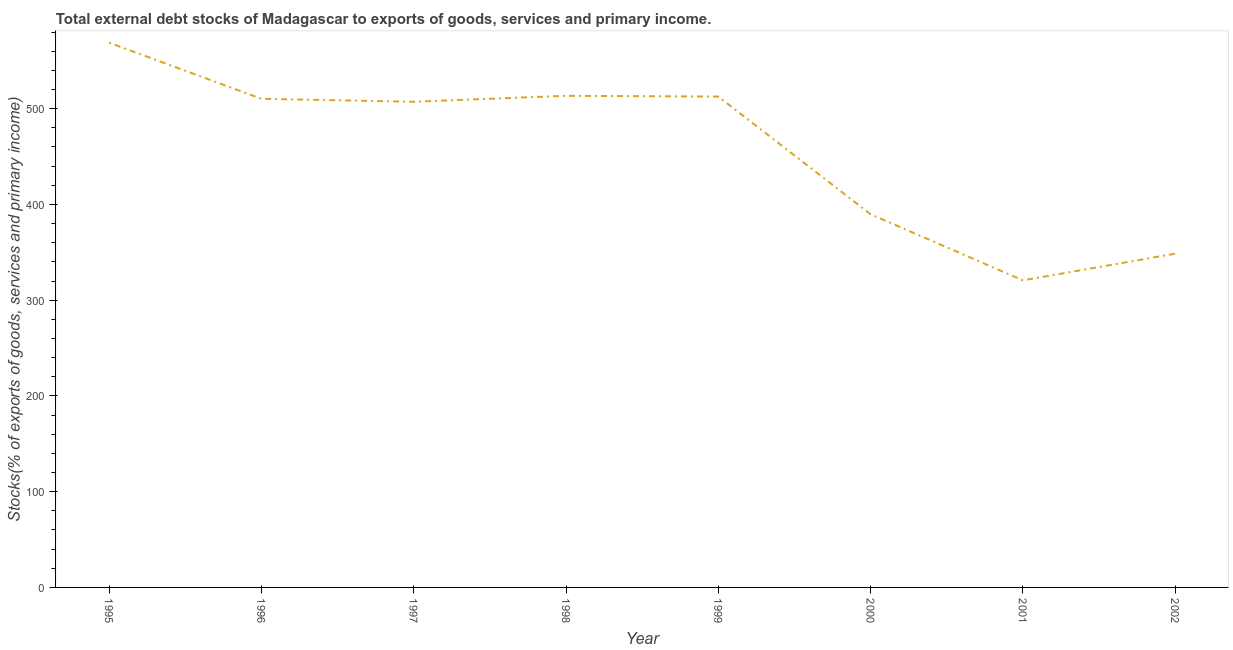What is the external debt stocks in 2002?
Provide a short and direct response. 348.57. Across all years, what is the maximum external debt stocks?
Make the answer very short. 568.87. Across all years, what is the minimum external debt stocks?
Your answer should be very brief. 320.68. In which year was the external debt stocks maximum?
Provide a short and direct response. 1995. What is the sum of the external debt stocks?
Offer a terse response. 3671.37. What is the difference between the external debt stocks in 1995 and 2000?
Your answer should be compact. 179.17. What is the average external debt stocks per year?
Ensure brevity in your answer.  458.92. What is the median external debt stocks?
Make the answer very short. 508.76. In how many years, is the external debt stocks greater than 160 %?
Your response must be concise. 8. What is the ratio of the external debt stocks in 1996 to that in 1997?
Your answer should be compact. 1.01. What is the difference between the highest and the second highest external debt stocks?
Ensure brevity in your answer.  55.46. Is the sum of the external debt stocks in 1996 and 2001 greater than the maximum external debt stocks across all years?
Provide a succinct answer. Yes. What is the difference between the highest and the lowest external debt stocks?
Provide a short and direct response. 248.19. What is the difference between two consecutive major ticks on the Y-axis?
Provide a succinct answer. 100. Are the values on the major ticks of Y-axis written in scientific E-notation?
Your answer should be compact. No. Does the graph contain grids?
Offer a very short reply. No. What is the title of the graph?
Offer a very short reply. Total external debt stocks of Madagascar to exports of goods, services and primary income. What is the label or title of the X-axis?
Your answer should be compact. Year. What is the label or title of the Y-axis?
Provide a short and direct response. Stocks(% of exports of goods, services and primary income). What is the Stocks(% of exports of goods, services and primary income) in 1995?
Provide a succinct answer. 568.87. What is the Stocks(% of exports of goods, services and primary income) in 1996?
Offer a terse response. 510.3. What is the Stocks(% of exports of goods, services and primary income) of 1997?
Your answer should be compact. 507.21. What is the Stocks(% of exports of goods, services and primary income) in 1998?
Make the answer very short. 513.41. What is the Stocks(% of exports of goods, services and primary income) of 1999?
Ensure brevity in your answer.  512.61. What is the Stocks(% of exports of goods, services and primary income) in 2000?
Your answer should be compact. 389.71. What is the Stocks(% of exports of goods, services and primary income) of 2001?
Provide a short and direct response. 320.68. What is the Stocks(% of exports of goods, services and primary income) of 2002?
Make the answer very short. 348.57. What is the difference between the Stocks(% of exports of goods, services and primary income) in 1995 and 1996?
Give a very brief answer. 58.57. What is the difference between the Stocks(% of exports of goods, services and primary income) in 1995 and 1997?
Keep it short and to the point. 61.66. What is the difference between the Stocks(% of exports of goods, services and primary income) in 1995 and 1998?
Your answer should be very brief. 55.46. What is the difference between the Stocks(% of exports of goods, services and primary income) in 1995 and 1999?
Make the answer very short. 56.26. What is the difference between the Stocks(% of exports of goods, services and primary income) in 1995 and 2000?
Provide a succinct answer. 179.17. What is the difference between the Stocks(% of exports of goods, services and primary income) in 1995 and 2001?
Offer a terse response. 248.19. What is the difference between the Stocks(% of exports of goods, services and primary income) in 1995 and 2002?
Give a very brief answer. 220.3. What is the difference between the Stocks(% of exports of goods, services and primary income) in 1996 and 1997?
Give a very brief answer. 3.09. What is the difference between the Stocks(% of exports of goods, services and primary income) in 1996 and 1998?
Make the answer very short. -3.11. What is the difference between the Stocks(% of exports of goods, services and primary income) in 1996 and 1999?
Keep it short and to the point. -2.31. What is the difference between the Stocks(% of exports of goods, services and primary income) in 1996 and 2000?
Your response must be concise. 120.59. What is the difference between the Stocks(% of exports of goods, services and primary income) in 1996 and 2001?
Make the answer very short. 189.62. What is the difference between the Stocks(% of exports of goods, services and primary income) in 1996 and 2002?
Offer a terse response. 161.73. What is the difference between the Stocks(% of exports of goods, services and primary income) in 1997 and 1998?
Give a very brief answer. -6.2. What is the difference between the Stocks(% of exports of goods, services and primary income) in 1997 and 1999?
Keep it short and to the point. -5.4. What is the difference between the Stocks(% of exports of goods, services and primary income) in 1997 and 2000?
Offer a very short reply. 117.51. What is the difference between the Stocks(% of exports of goods, services and primary income) in 1997 and 2001?
Offer a very short reply. 186.53. What is the difference between the Stocks(% of exports of goods, services and primary income) in 1997 and 2002?
Keep it short and to the point. 158.64. What is the difference between the Stocks(% of exports of goods, services and primary income) in 1998 and 1999?
Your answer should be compact. 0.8. What is the difference between the Stocks(% of exports of goods, services and primary income) in 1998 and 2000?
Your response must be concise. 123.7. What is the difference between the Stocks(% of exports of goods, services and primary income) in 1998 and 2001?
Give a very brief answer. 192.73. What is the difference between the Stocks(% of exports of goods, services and primary income) in 1998 and 2002?
Offer a very short reply. 164.84. What is the difference between the Stocks(% of exports of goods, services and primary income) in 1999 and 2000?
Your response must be concise. 122.9. What is the difference between the Stocks(% of exports of goods, services and primary income) in 1999 and 2001?
Your answer should be very brief. 191.93. What is the difference between the Stocks(% of exports of goods, services and primary income) in 1999 and 2002?
Your answer should be compact. 164.04. What is the difference between the Stocks(% of exports of goods, services and primary income) in 2000 and 2001?
Make the answer very short. 69.03. What is the difference between the Stocks(% of exports of goods, services and primary income) in 2000 and 2002?
Ensure brevity in your answer.  41.14. What is the difference between the Stocks(% of exports of goods, services and primary income) in 2001 and 2002?
Offer a very short reply. -27.89. What is the ratio of the Stocks(% of exports of goods, services and primary income) in 1995 to that in 1996?
Provide a short and direct response. 1.11. What is the ratio of the Stocks(% of exports of goods, services and primary income) in 1995 to that in 1997?
Your answer should be compact. 1.12. What is the ratio of the Stocks(% of exports of goods, services and primary income) in 1995 to that in 1998?
Keep it short and to the point. 1.11. What is the ratio of the Stocks(% of exports of goods, services and primary income) in 1995 to that in 1999?
Give a very brief answer. 1.11. What is the ratio of the Stocks(% of exports of goods, services and primary income) in 1995 to that in 2000?
Keep it short and to the point. 1.46. What is the ratio of the Stocks(% of exports of goods, services and primary income) in 1995 to that in 2001?
Your response must be concise. 1.77. What is the ratio of the Stocks(% of exports of goods, services and primary income) in 1995 to that in 2002?
Offer a terse response. 1.63. What is the ratio of the Stocks(% of exports of goods, services and primary income) in 1996 to that in 1997?
Provide a short and direct response. 1.01. What is the ratio of the Stocks(% of exports of goods, services and primary income) in 1996 to that in 2000?
Your answer should be very brief. 1.31. What is the ratio of the Stocks(% of exports of goods, services and primary income) in 1996 to that in 2001?
Offer a very short reply. 1.59. What is the ratio of the Stocks(% of exports of goods, services and primary income) in 1996 to that in 2002?
Make the answer very short. 1.46. What is the ratio of the Stocks(% of exports of goods, services and primary income) in 1997 to that in 2000?
Provide a succinct answer. 1.3. What is the ratio of the Stocks(% of exports of goods, services and primary income) in 1997 to that in 2001?
Give a very brief answer. 1.58. What is the ratio of the Stocks(% of exports of goods, services and primary income) in 1997 to that in 2002?
Make the answer very short. 1.46. What is the ratio of the Stocks(% of exports of goods, services and primary income) in 1998 to that in 2000?
Give a very brief answer. 1.32. What is the ratio of the Stocks(% of exports of goods, services and primary income) in 1998 to that in 2001?
Ensure brevity in your answer.  1.6. What is the ratio of the Stocks(% of exports of goods, services and primary income) in 1998 to that in 2002?
Offer a terse response. 1.47. What is the ratio of the Stocks(% of exports of goods, services and primary income) in 1999 to that in 2000?
Your response must be concise. 1.31. What is the ratio of the Stocks(% of exports of goods, services and primary income) in 1999 to that in 2001?
Provide a short and direct response. 1.6. What is the ratio of the Stocks(% of exports of goods, services and primary income) in 1999 to that in 2002?
Offer a terse response. 1.47. What is the ratio of the Stocks(% of exports of goods, services and primary income) in 2000 to that in 2001?
Ensure brevity in your answer.  1.22. What is the ratio of the Stocks(% of exports of goods, services and primary income) in 2000 to that in 2002?
Keep it short and to the point. 1.12. 